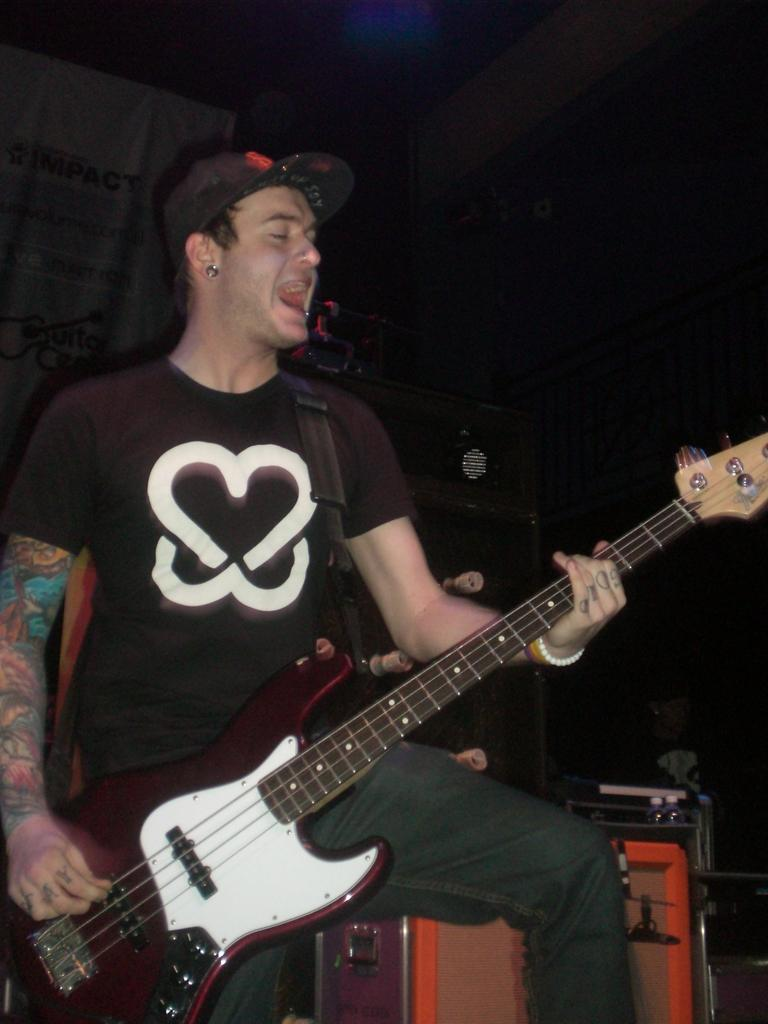Who is present in the image? There is a man in the image. What is the man doing in the image? The man is standing in the image. What object is the man holding in the image? The man is holding a guitar in the image. What can be seen in the background of the image? There is equipment visible in the background of the image. What type of laborer is working at the airport in the image? There is no laborer or airport present in the image; it features a man holding a guitar. 